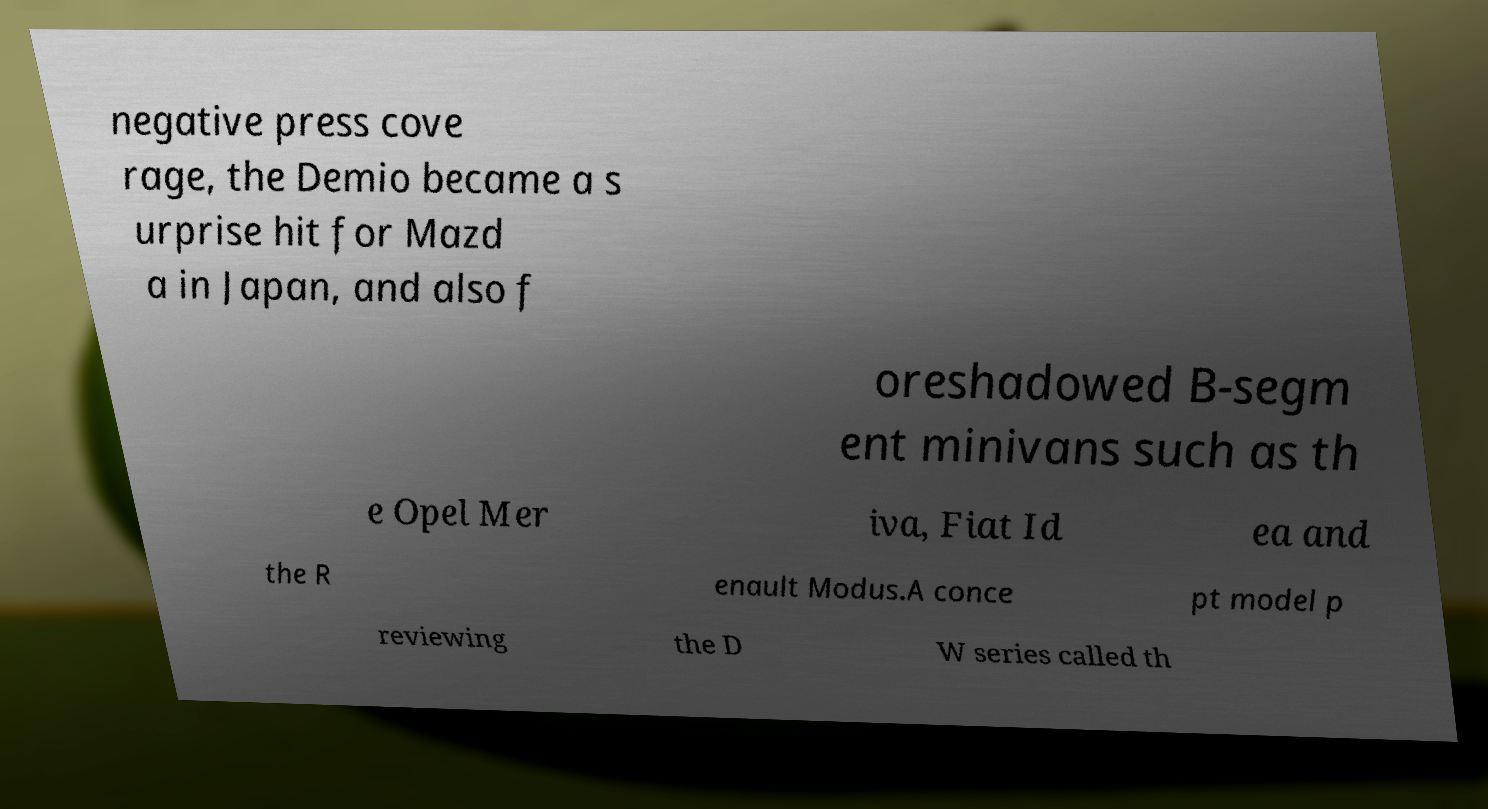There's text embedded in this image that I need extracted. Can you transcribe it verbatim? negative press cove rage, the Demio became a s urprise hit for Mazd a in Japan, and also f oreshadowed B-segm ent minivans such as th e Opel Mer iva, Fiat Id ea and the R enault Modus.A conce pt model p reviewing the D W series called th 